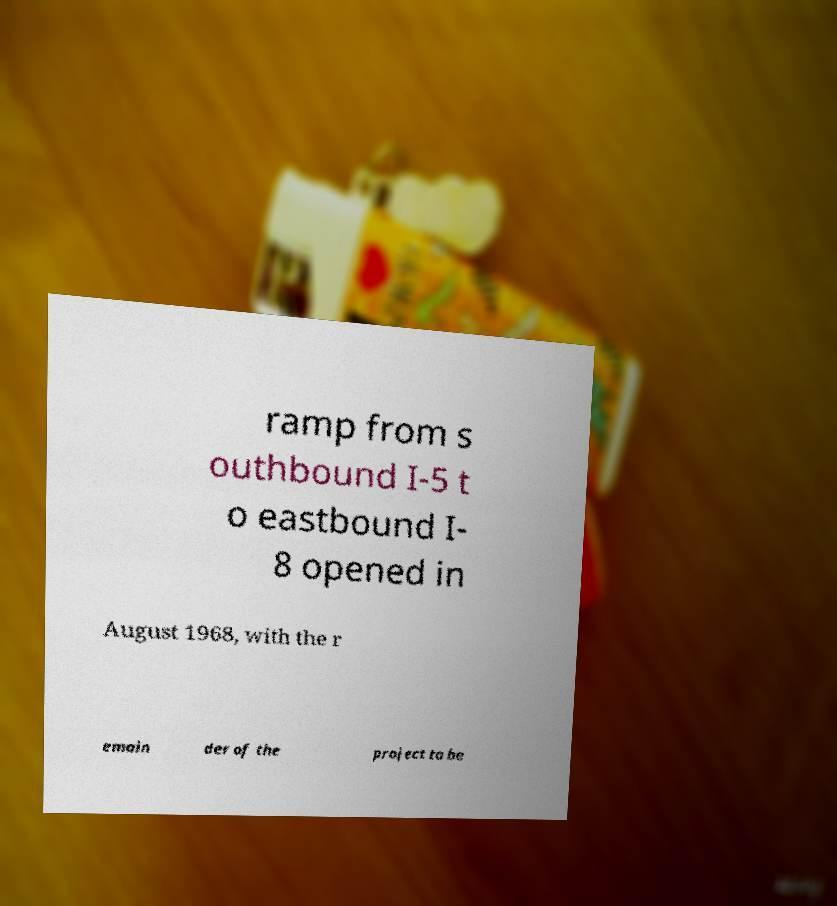Could you assist in decoding the text presented in this image and type it out clearly? ramp from s outhbound I-5 t o eastbound I- 8 opened in August 1968, with the r emain der of the project to be 